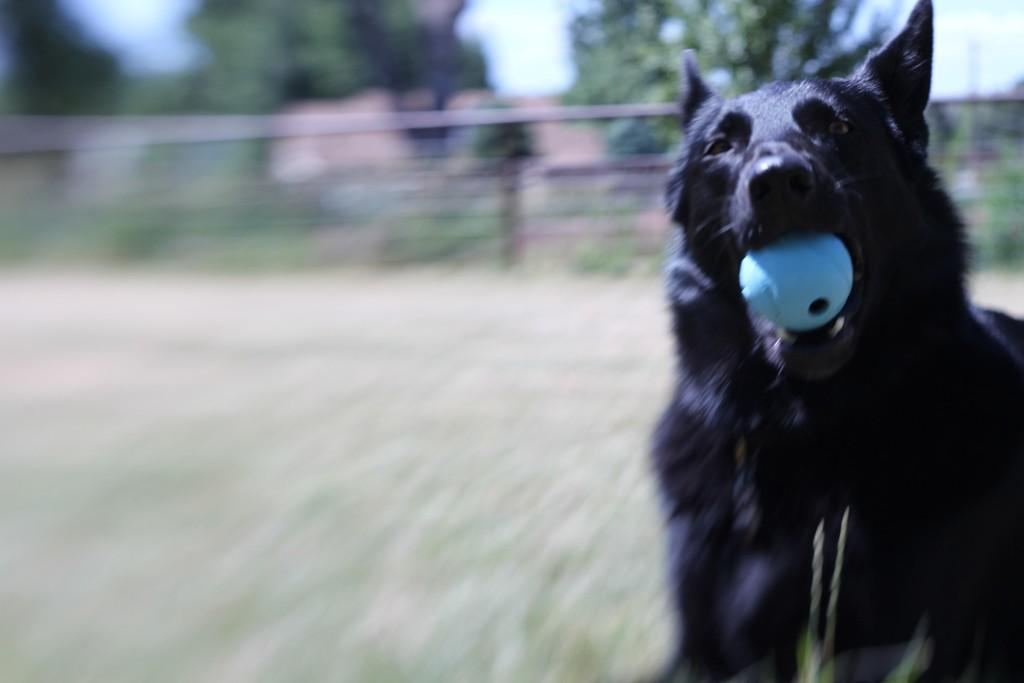What animal can be seen in the image? There is a dog in the image. What is the dog holding in its mouth? The dog is holding a ball in its mouth. What is located behind the dog? There is a metal mesh fence behind the dog. What can be seen beyond the fence? Trees and houses are visible behind the fence. In which direction is the dog's partner walking in the image? There is no partner or walking mentioned in the image; it only shows a dog holding a ball with a fence and trees in the background. 